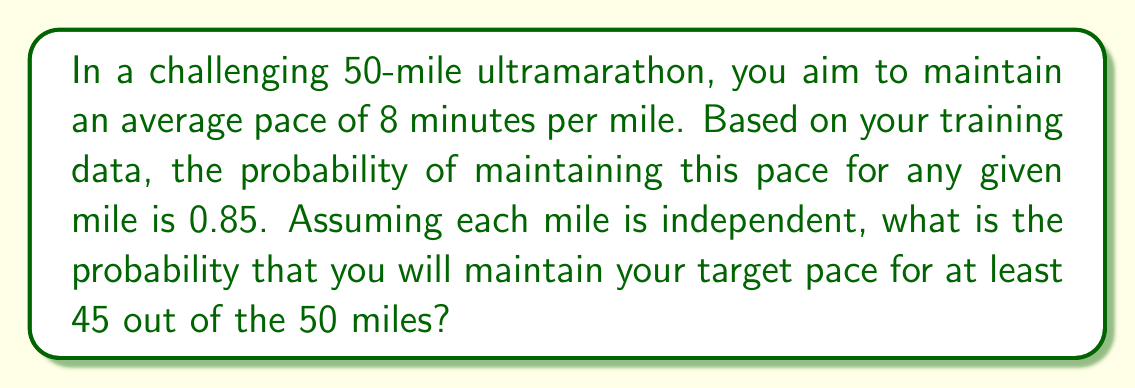Provide a solution to this math problem. Let's approach this step-by-step:

1) This scenario follows a binomial distribution, where:
   n = 50 (total number of miles)
   p = 0.85 (probability of success for each mile)
   k ≥ 45 (we want at least 45 successes)

2) We need to calculate P(X ≥ 45), where X is the number of miles at target pace.

3) This is equivalent to 1 - P(X < 45) = 1 - P(X ≤ 44)

4) The probability mass function for a binomial distribution is:

   $$P(X = k) = \binom{n}{k} p^k (1-p)^{n-k}$$

5) We need to sum this for k = 45 to 50:

   $$P(X \geq 45) = \sum_{k=45}^{50} \binom{50}{k} 0.85^k (1-0.85)^{50-k}$$

6) Using the binomial cumulative distribution function (CDF), we can calculate:

   $$P(X \geq 45) = 1 - P(X \leq 44)$$

7) Using a calculator or programming language with a binomial CDF function:

   $$P(X \geq 45) = 1 - 0.0728 = 0.9272$$

Thus, the probability of maintaining the target pace for at least 45 out of 50 miles is approximately 0.9272 or 92.72%.
Answer: 0.9272 